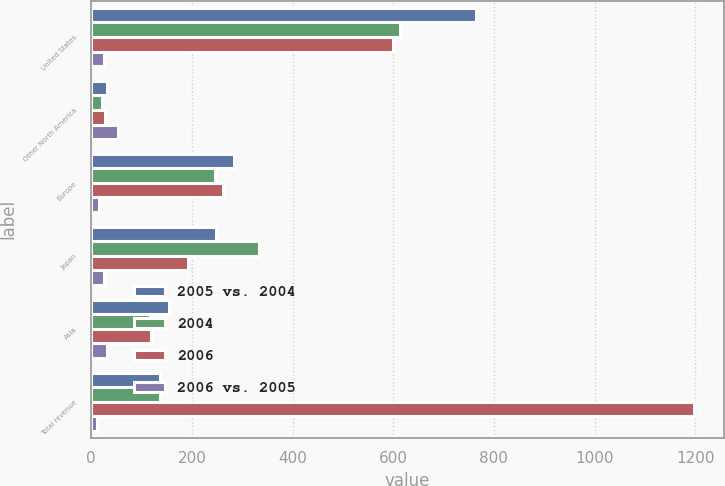Convert chart. <chart><loc_0><loc_0><loc_500><loc_500><stacked_bar_chart><ecel><fcel>United States<fcel>Other North America<fcel>Europe<fcel>Japan<fcel>Asia<fcel>Total revenue<nl><fcel>2005 vs. 2004<fcel>765.1<fcel>31.3<fcel>284.4<fcel>247.9<fcel>155.2<fcel>136.85<nl><fcel>2004<fcel>613.2<fcel>20.3<fcel>245<fcel>333.2<fcel>117.5<fcel>136.85<nl><fcel>2006<fcel>598.9<fcel>27<fcel>261.9<fcel>191.2<fcel>118.5<fcel>1197.5<nl><fcel>2006 vs. 2005<fcel>25<fcel>54<fcel>16<fcel>26<fcel>32<fcel>12<nl></chart> 